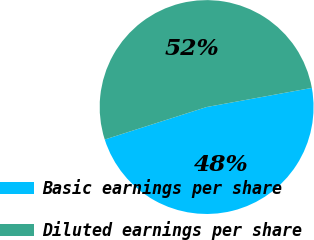Convert chart to OTSL. <chart><loc_0><loc_0><loc_500><loc_500><pie_chart><fcel>Basic earnings per share<fcel>Diluted earnings per share<nl><fcel>47.95%<fcel>52.05%<nl></chart> 